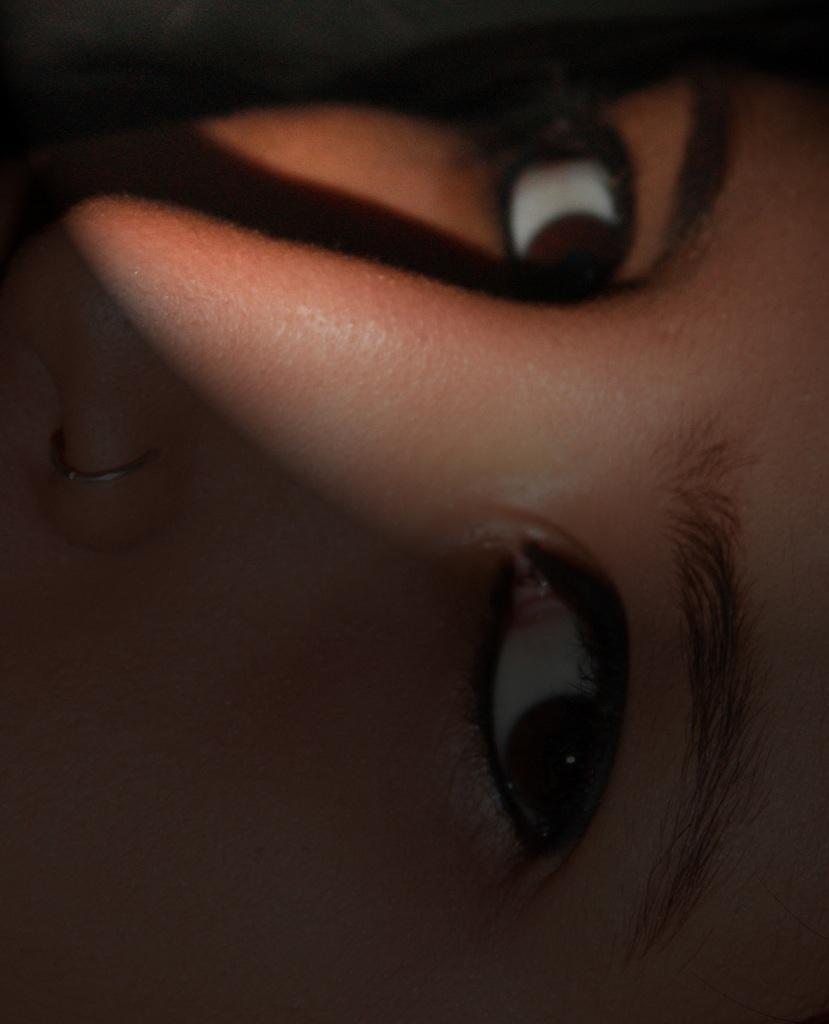Please provide a concise description of this image. We can see a person's face with eyebrows, eyes and nose with nose stud. 